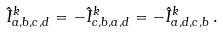Convert formula to latex. <formula><loc_0><loc_0><loc_500><loc_500>\hat { I } ^ { k } _ { a , b , c , d } = - \hat { I } ^ { k } _ { c , b , a , d } = - \hat { I } ^ { k } _ { a , d , c , b } \, .</formula> 